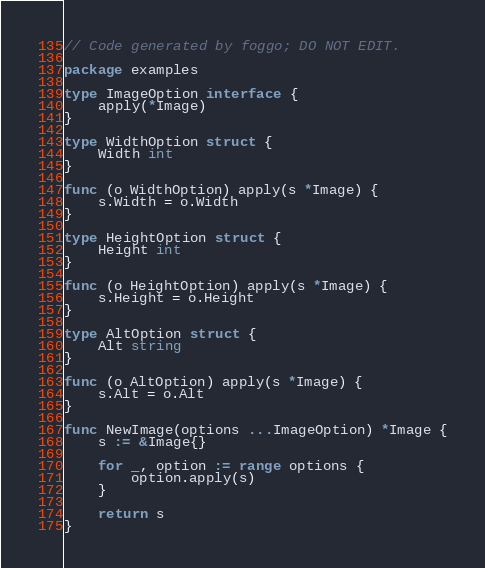Convert code to text. <code><loc_0><loc_0><loc_500><loc_500><_Go_>// Code generated by foggo; DO NOT EDIT.

package examples

type ImageOption interface {
	apply(*Image)
}

type WidthOption struct {
	Width int
}

func (o WidthOption) apply(s *Image) {
	s.Width = o.Width
}

type HeightOption struct {
	Height int
}

func (o HeightOption) apply(s *Image) {
	s.Height = o.Height
}

type AltOption struct {
	Alt string
}

func (o AltOption) apply(s *Image) {
	s.Alt = o.Alt
}

func NewImage(options ...ImageOption) *Image {
	s := &Image{}

	for _, option := range options {
		option.apply(s)
	}

	return s
}
</code> 